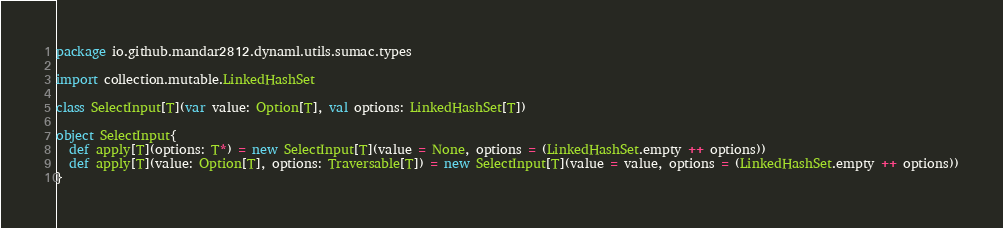Convert code to text. <code><loc_0><loc_0><loc_500><loc_500><_Scala_>package io.github.mandar2812.dynaml.utils.sumac.types

import collection.mutable.LinkedHashSet

class SelectInput[T](var value: Option[T], val options: LinkedHashSet[T])

object SelectInput{
  def apply[T](options: T*) = new SelectInput[T](value = None, options = (LinkedHashSet.empty ++ options))
  def apply[T](value: Option[T], options: Traversable[T]) = new SelectInput[T](value = value, options = (LinkedHashSet.empty ++ options))
}
</code> 